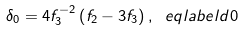<formula> <loc_0><loc_0><loc_500><loc_500>\delta _ { 0 } = 4 f _ { 3 } ^ { - 2 } \left ( f _ { 2 } - 3 f _ { 3 } \right ) , \ e q l a b e l { d 0 }</formula> 